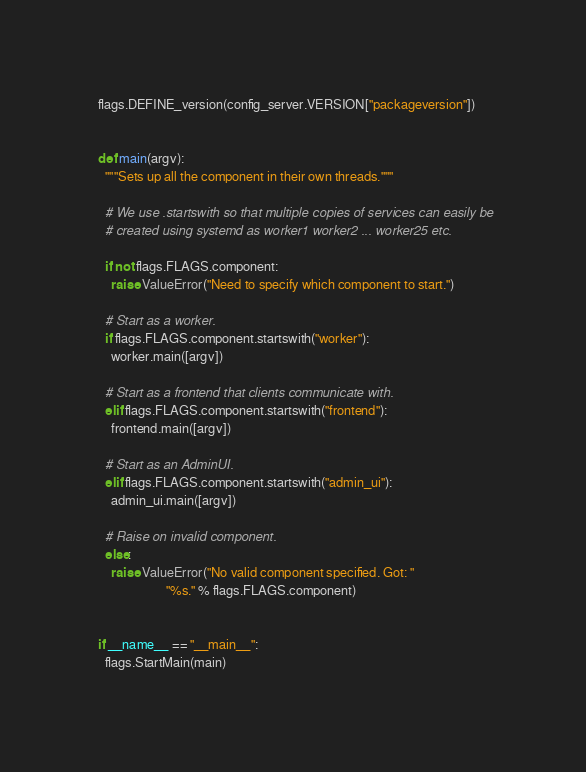<code> <loc_0><loc_0><loc_500><loc_500><_Python_>flags.DEFINE_version(config_server.VERSION["packageversion"])


def main(argv):
  """Sets up all the component in their own threads."""

  # We use .startswith so that multiple copies of services can easily be
  # created using systemd as worker1 worker2 ... worker25 etc.

  if not flags.FLAGS.component:
    raise ValueError("Need to specify which component to start.")

  # Start as a worker.
  if flags.FLAGS.component.startswith("worker"):
    worker.main([argv])

  # Start as a frontend that clients communicate with.
  elif flags.FLAGS.component.startswith("frontend"):
    frontend.main([argv])

  # Start as an AdminUI.
  elif flags.FLAGS.component.startswith("admin_ui"):
    admin_ui.main([argv])

  # Raise on invalid component.
  else:
    raise ValueError("No valid component specified. Got: "
                     "%s." % flags.FLAGS.component)


if __name__ == "__main__":
  flags.StartMain(main)
</code> 